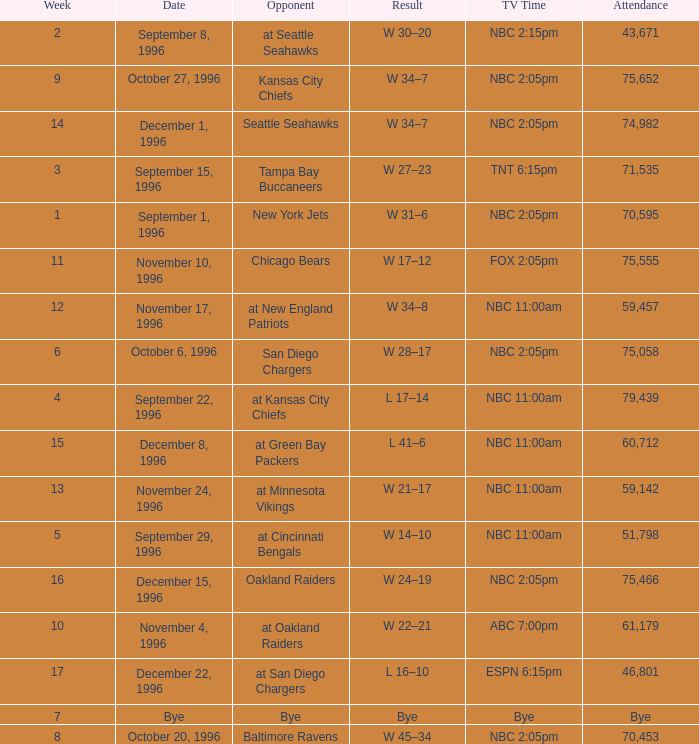WHAT IS THE TV TIME FOR NOVEMBER 10, 1996? FOX 2:05pm. 